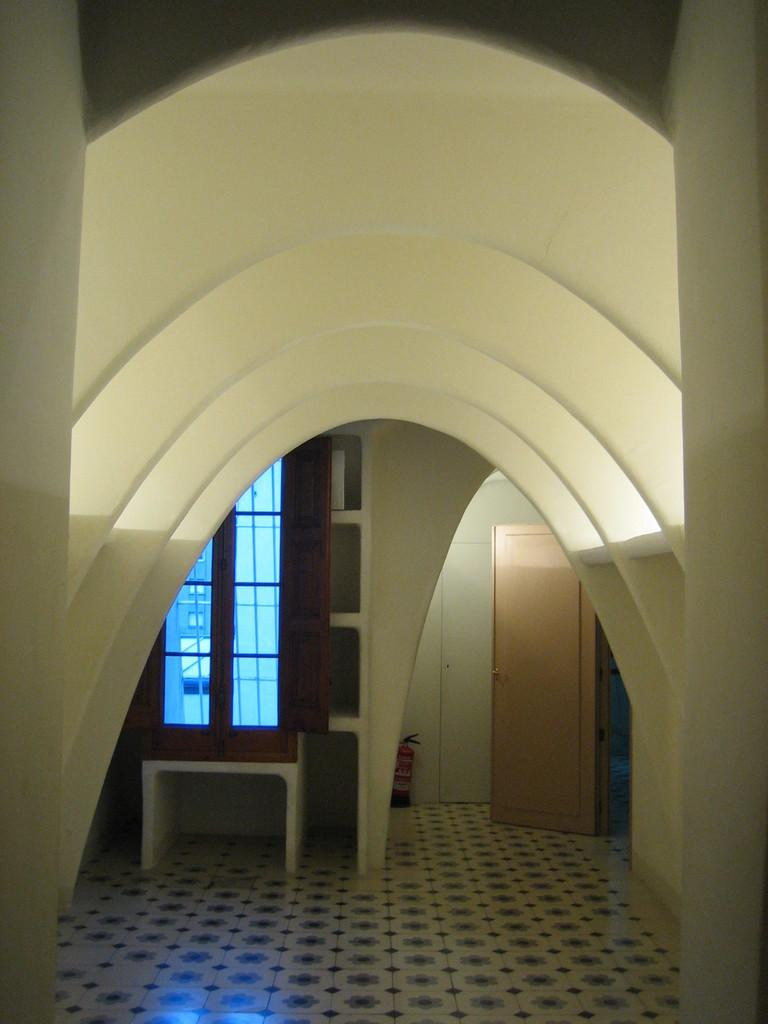What is one of the architectural features visible in the image? There is a door in the image. What safety device is present in the image? There is a fire extinguisher in the image. What type of structure can be seen in the image? There is a wall in the image. What can be used for viewing the outside environment? There is a window in the image. What objects are present on a surface in the image? There are glasses in the image. What surface is visible in the image? There is a floor in the image. What can be seen through the glasses in the image? A building is visible through the glasses in the image. What type of vegetable is being used as a mouthpiece for the fire extinguisher in the image? There is no vegetable present in the image, nor is it being used as a mouthpiece for the fire extinguisher. 